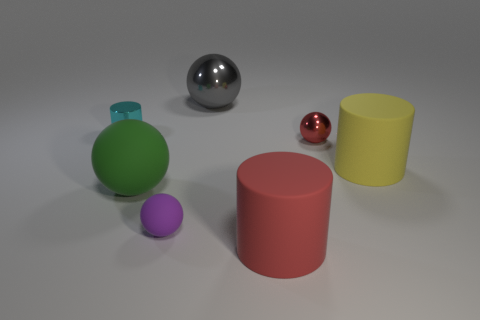Subtract 1 balls. How many balls are left? 3 Add 1 tiny matte spheres. How many objects exist? 8 Subtract all spheres. How many objects are left? 3 Add 5 big brown rubber things. How many big brown rubber things exist? 5 Subtract 0 purple cubes. How many objects are left? 7 Subtract all big gray shiny objects. Subtract all large green balls. How many objects are left? 5 Add 4 large gray metal things. How many large gray metal things are left? 5 